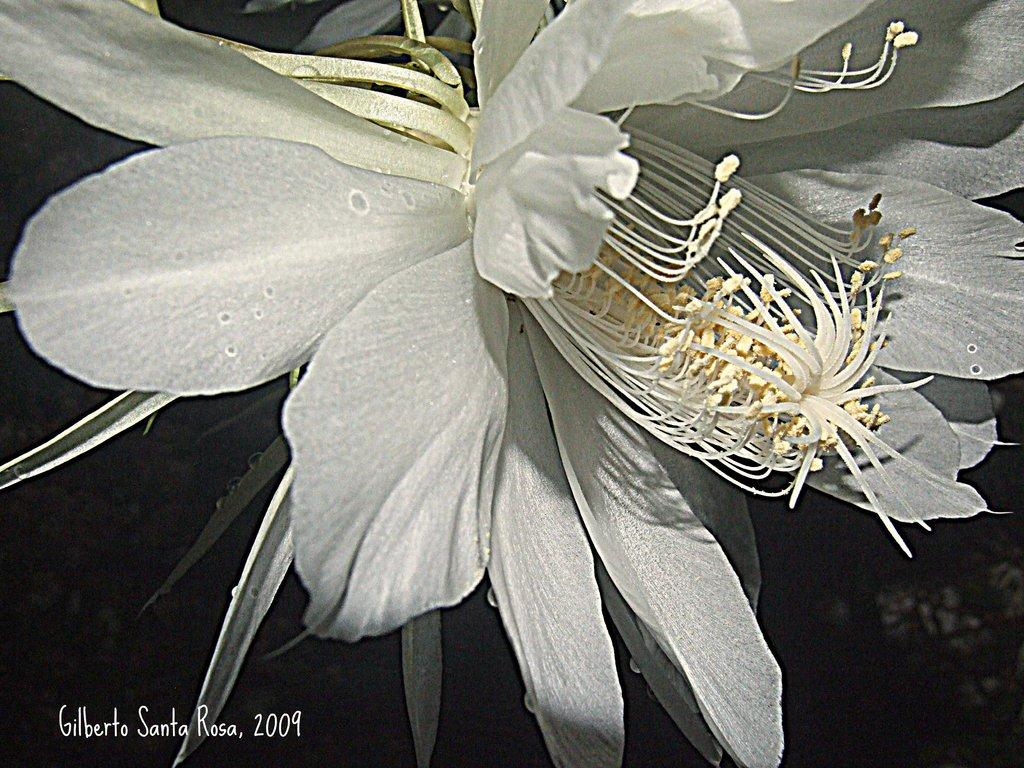What is the main subject of the image? There is a flower in the image. How would you describe the background of the image? The background of the image is dark. Can you identify any additional text or information in the image? Yes, there is text and a year in the bottom left side of the image. How many children are playing in the flower garden in the image? There are no children present in the image; it features a single flower with a dark background and text in the bottom left side. What type of metal is used to create the fence surrounding the flower in the image? There is no fence visible in the image, and therefore no metal can be identified. 